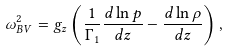<formula> <loc_0><loc_0><loc_500><loc_500>\omega _ { B V } ^ { 2 } = g _ { z } \left ( \frac { 1 } { \Gamma _ { 1 } } \frac { d \ln p } { d z } - \frac { d \ln \rho } { d z } \right ) ,</formula> 